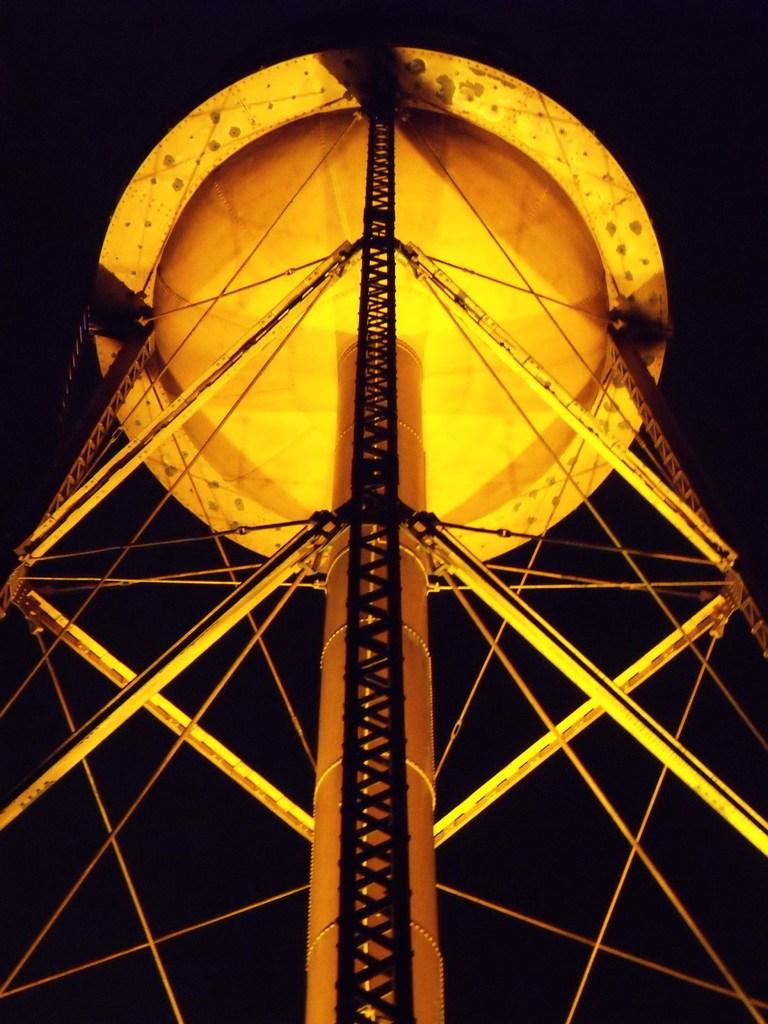What is the main structure visible in the image? There is a tower in the image. What material are the rods in the image made of? The rods in the image are made of metal. What type of copper is being used to build the cattle in the image? There is no copper or cattle present in the image; it only features a tower and metal rods. 